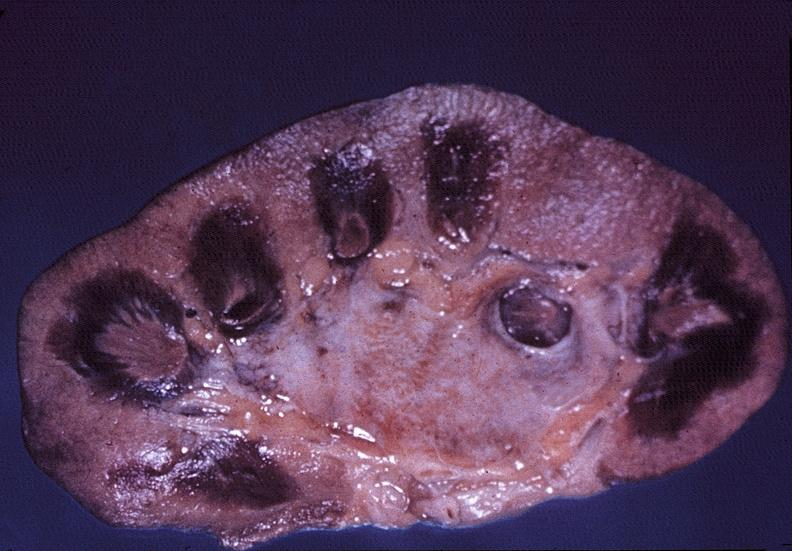does this image show kidney, papillitis, necrotizing?
Answer the question using a single word or phrase. Yes 